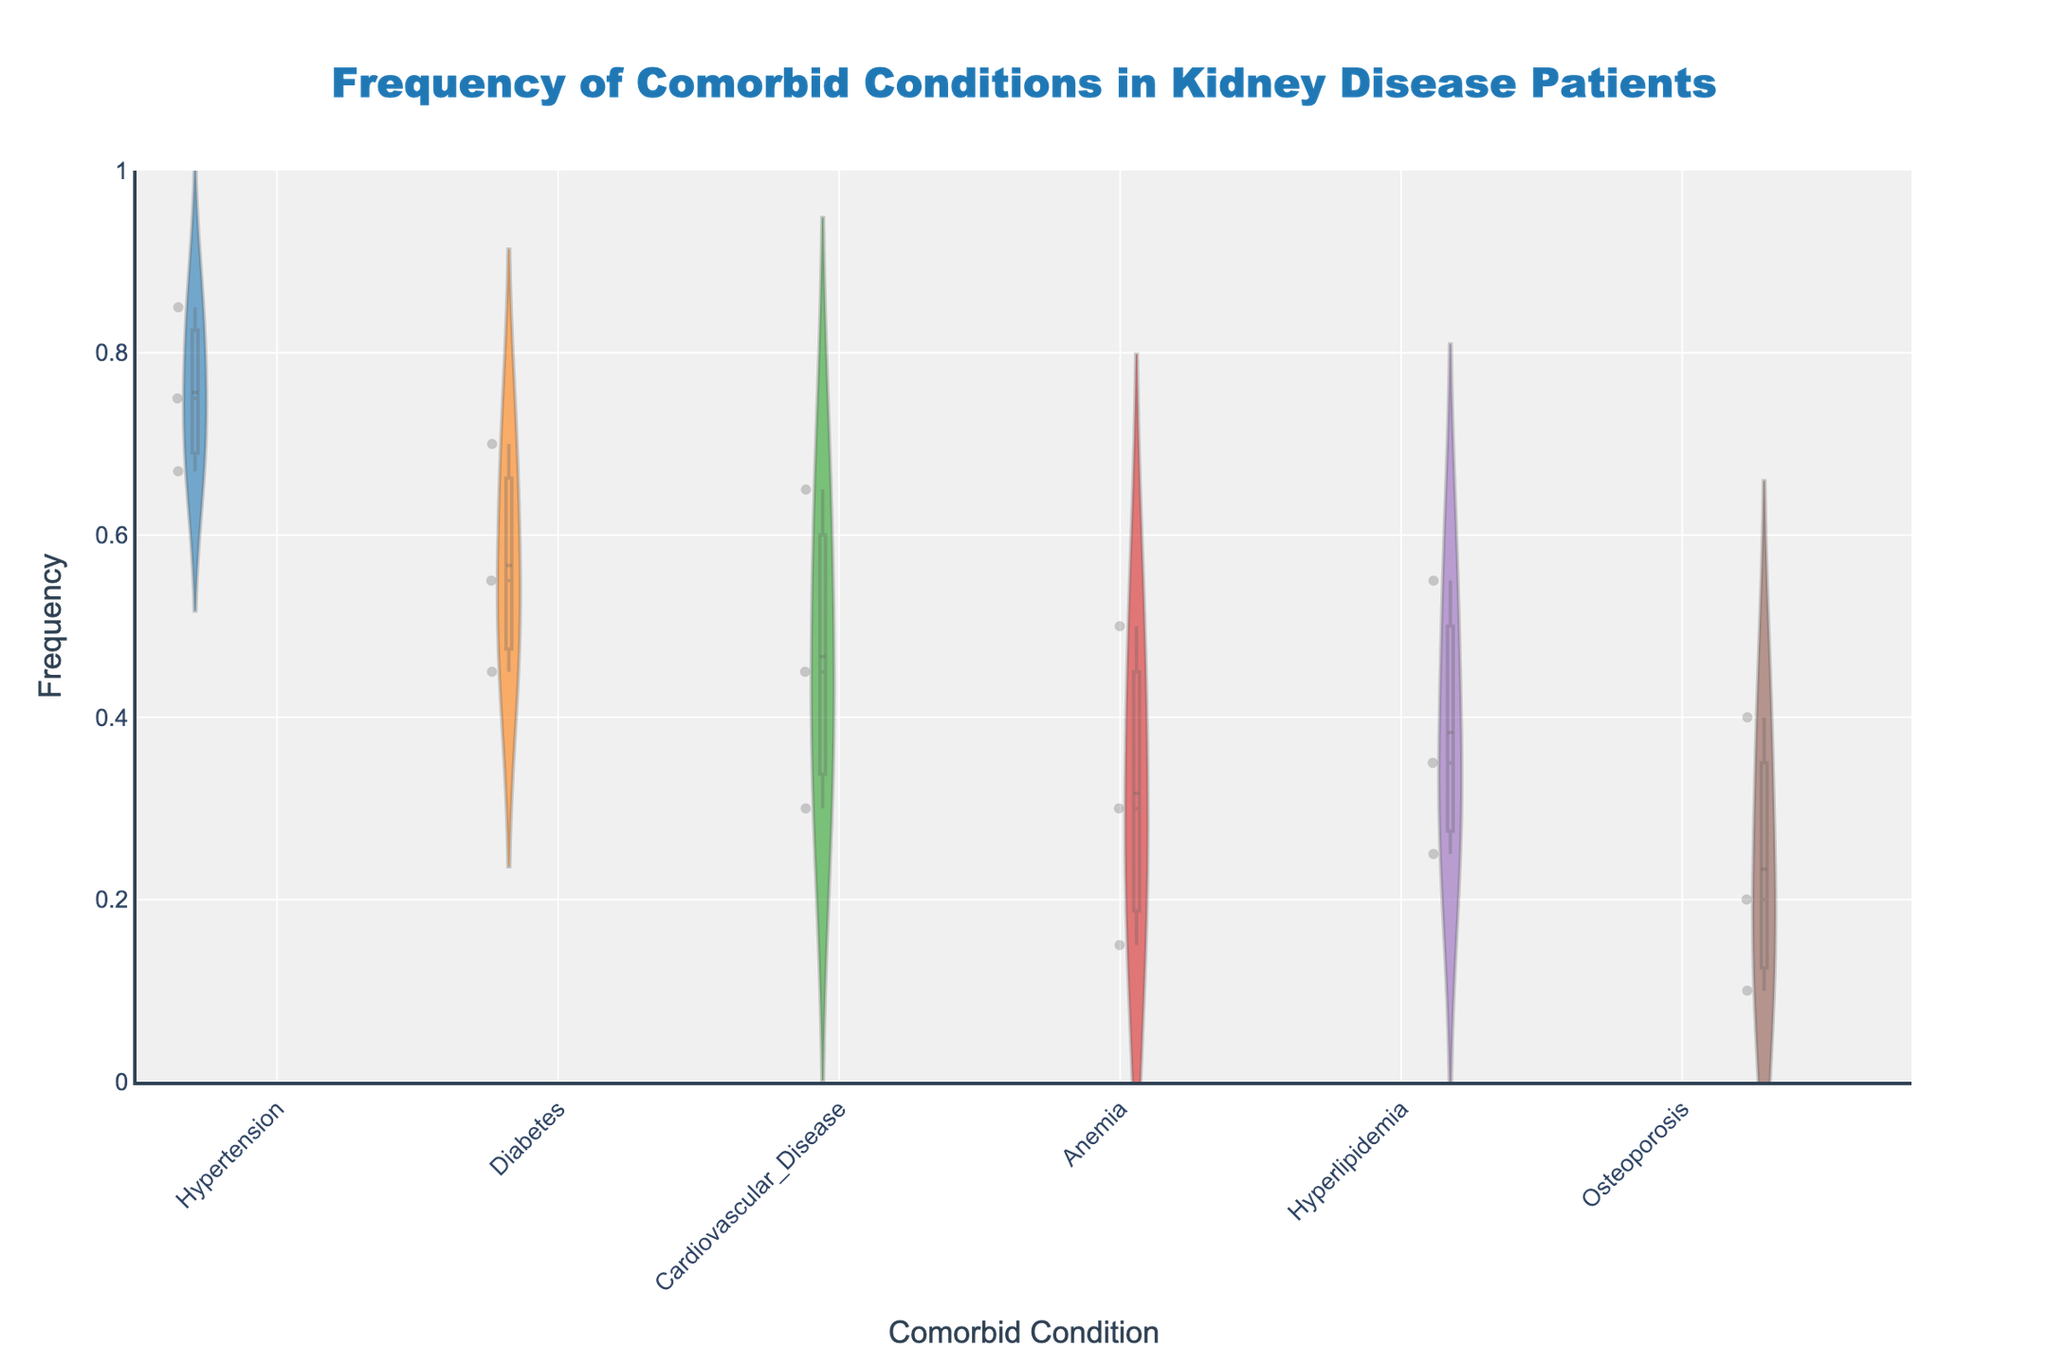What is the title of the figure? The title is located at the top of the figure and it indicates what the chart is about. To find the title, simply refer to this section of the chart.
Answer: Frequency of Comorbid Conditions in Kidney Disease Patients Which comorbid condition shows the highest frequency in severe kidney disease patients? By looking at the section of the plot corresponding to severe kidney disease for each comorbid condition, compare the frequencies. Hypertension has the highest frequency of 0.85.
Answer: Hypertension What is the mean frequency of diabetes across all severity levels in kidney disease patients? To find the mean frequency, add the frequencies of diabetes at each severity level and divide by the number of levels. The frequencies are 0.45, 0.55, and 0.70. The calculation is (0.45 + 0.55 + 0.70)/3 = 1.70/3 = 0.5667.
Answer: 0.57 How does the frequency of anemia change from mild to severe kidney disease? To determine the change, find the frequency of anemia at mild, moderate, and severe levels, and observe the trend. Frequencies are 0.15, 0.30, and 0.50, showing an increasing trend as severity increases.
Answer: Increases Which comorbid condition has the smallest increase in frequency from mild to severe kidney disease? Calculate the increase in frequency by subtracting the mild frequency from the severe frequency for each condition. Identify the smallest increase. Osteoporosis increases from 0.10 to 0.40, an increase of 0.30, which is smaller than other conditions.
Answer: Osteoporosis How does the frequency of cardiovascular disease compare to hyperlipidemia in moderate kidney disease patients? Compare the plotted frequencies of cardiovascular disease and hyperlipidemia for moderate severity. Cardiovascular disease is 0.45, whereas hyperlipidemia is 0.35.
Answer: Cardiovascular disease is higher What is the average frequency of the comorbid conditions in mild kidney disease patients? To find the average, sum the frequencies of all comorbid conditions in mild patients and divide by the number of conditions. Frequencies are 0.67, 0.45, 0.30, 0.15, 0.25, and 0.10. The calculation is (0.67 + 0.45 + 0.30 + 0.15 + 0.25 + 0.10) / 6 = 1.92 / 6 = 0.32.
Answer: 0.32 Which severity of kidney disease has the highest mean frequency of hypertension, diabetes, and cardiovascular disease combined? Calculate the mean frequency for each severity by averaging the frequencies of hypertension, diabetes, and cardiovascular disease for each severity. 
Mild: (0.67 + 0.45 + 0.30)/3 = 0.4733,
Moderate: (0.75 + 0.55 + 0.45)/3 = 0.5833,
Severe (0.85 + 0.70 + 0.65)/3 = 0.7333.
Severe has the highest mean frequency.
Answer: Severe What is the range of frequencies for hypertension across all severity levels of kidney disease? The range is the difference between the maximum and minimum frequencies. For hypertension, the frequencies are 0.67, 0.75, and 0.85. The range is 0.85 - 0.67 = 0.18.
Answer: 0.18 